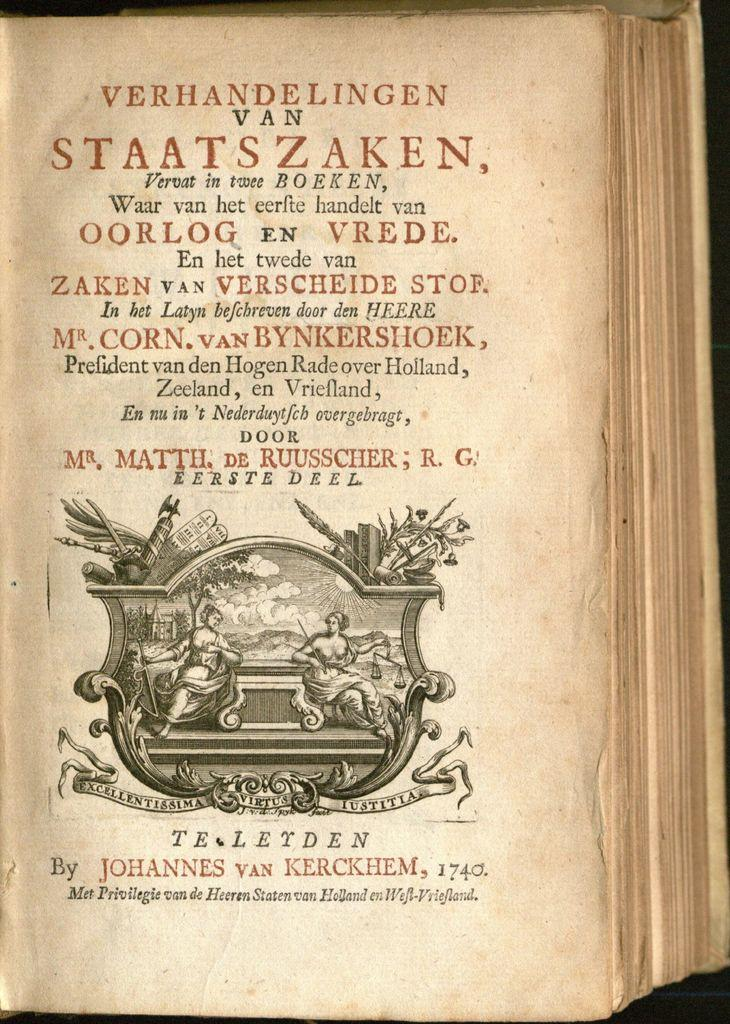<image>
Create a compact narrative representing the image presented. The title page in a book by Johannes Van Kerckhem written in 1740. 